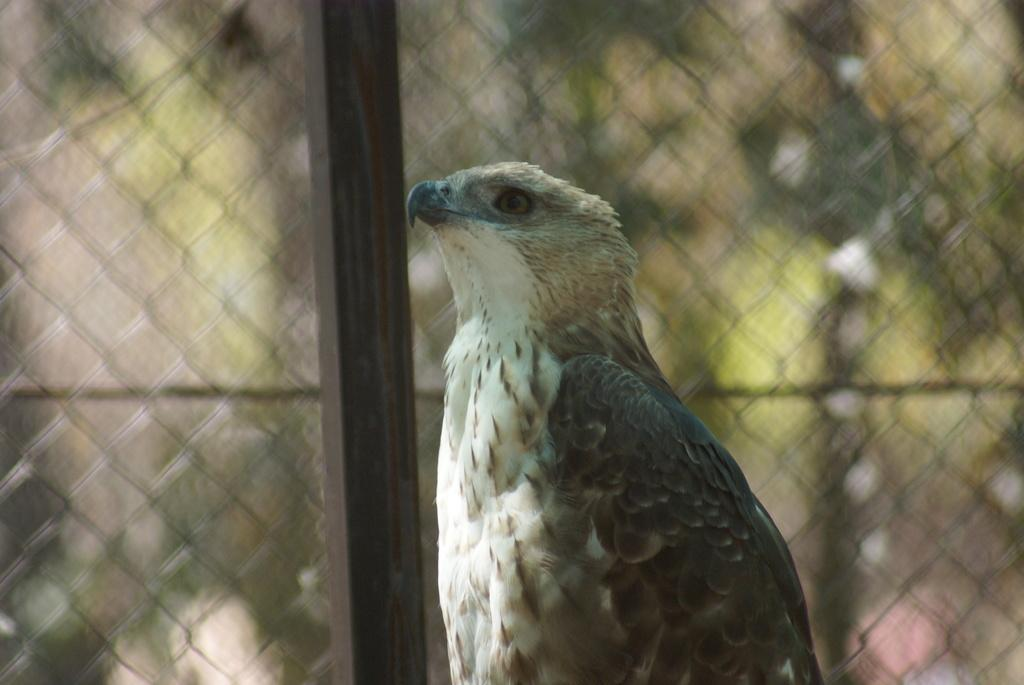What is the main subject in the center of the image? There is a bird in the center of the image. What can be seen in the background of the image? There is a fencing in the background of the image. Where are the cows and the frog located in the image? There are no cows or frogs present in the image. 